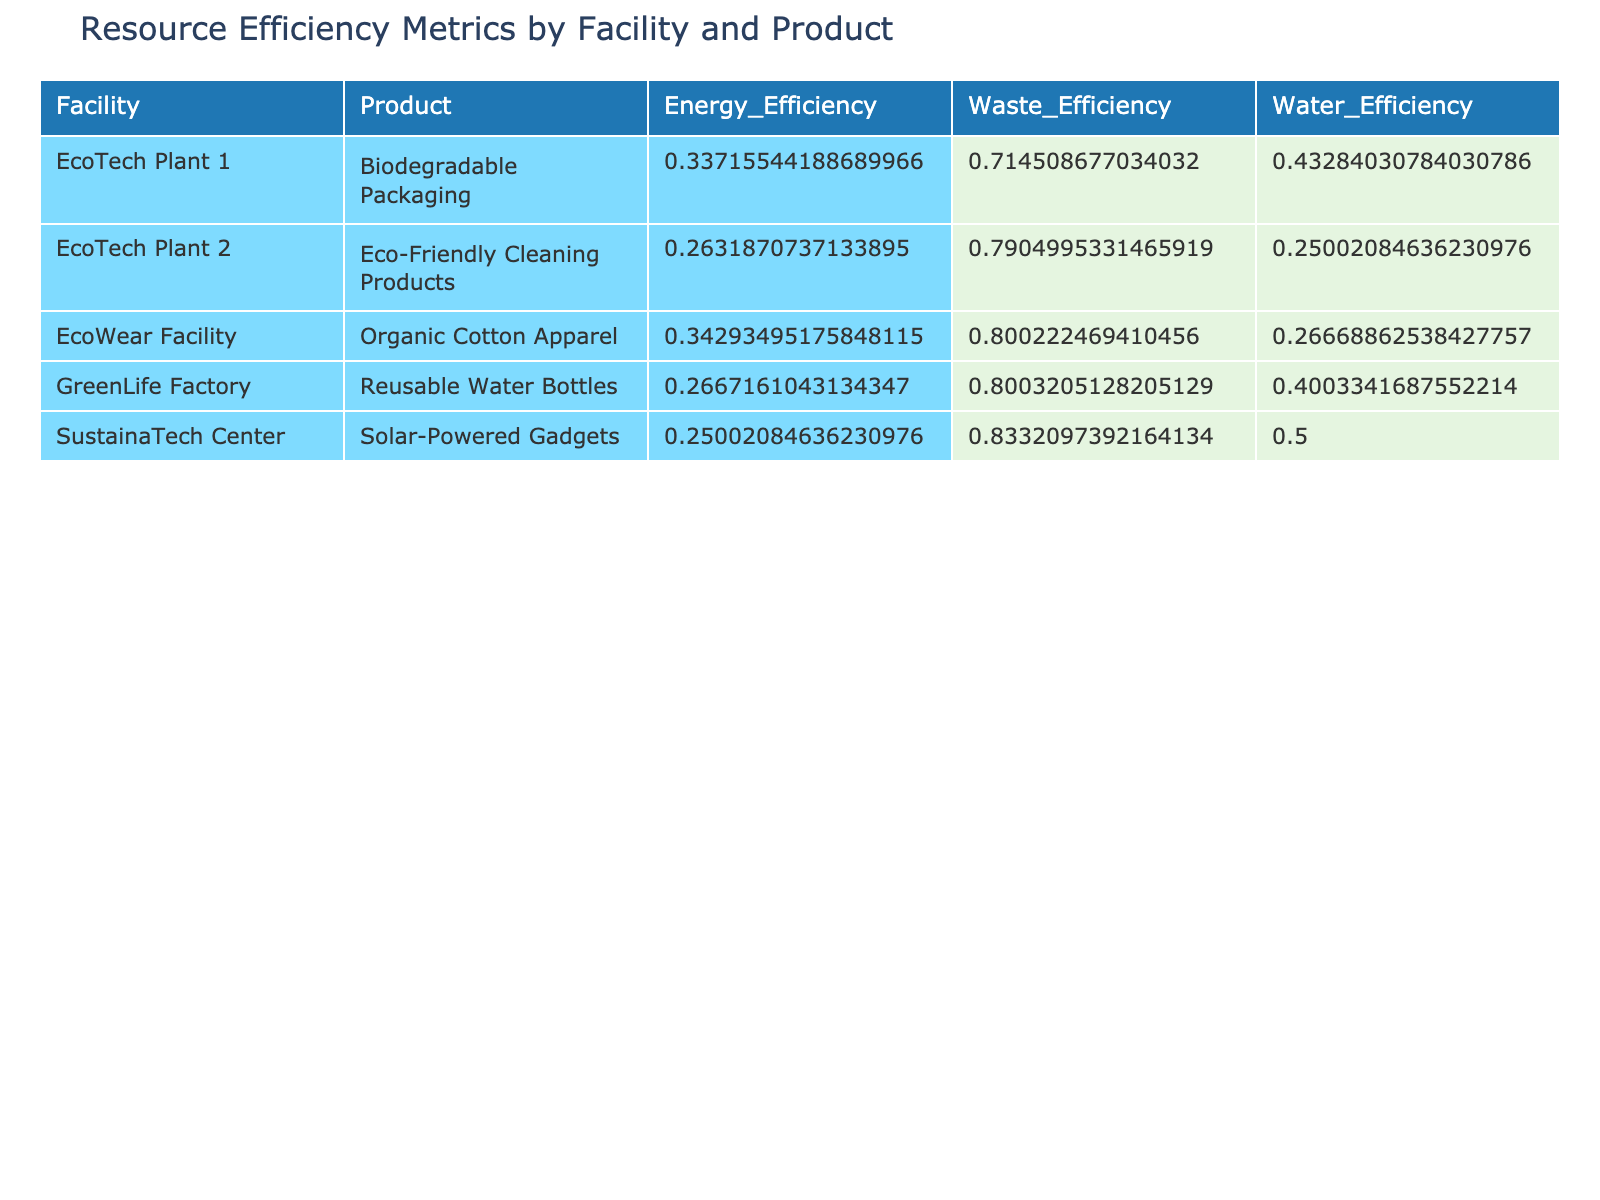What is the energy efficiency of EcoTech Plant 1 for the Biodegradable Packaging product? The table shows the energy efficiency metric under "Energy_Efficiency" for EcoTech Plant 1, Biodegradable Packaging listed as the average of its monthly values. Adding the values (0.333, 0.341, 0.326) gives 1.00, and dividing by 3 results in an average energy efficiency of approximately 0.333 kWh per production unit.
Answer: 0.333 Which facility produces the most waste per production unit? To find this, we compare the Waste Efficiency metrics. The waste efficiency values from the table show that the facility with the lowest value indicates the most waste produced per production unit, which is EcoTech Plant 1 for Biodegradable Packaging, with values averaging waste efficiency of 0.705.
Answer: EcoTech Plant 1 Is the water usage efficiency for EcoWear Facility higher than that for EcoTech Plant 2? From the table, EcoWear Facility's water efficiency averages to approximately 0.266, while EcoTech Plant 2's averages to 0.263. Comparing these values shows that EcoWear Facility has slightly higher water usage efficiency than EcoTech Plant 2 by about 0.003.
Answer: Yes What is the average waste produced across all facilities for the month of January? To calculate this, we first sum all waste produced in January: (8500 + 7000 + 5000 + 3000 + 6000) = 29000 kg. Then, we divide by the number of facilities (5), giving an average waste produced per facility of 5800 kg for January.
Answer: 5800 kg Which product had the best energy efficiency across all facilities on average? The energy efficiency values should be averaged for each product: (both the energy efficiencies calculated above). Biodegradable Packaging from EcoTech Plant 1 averaged 0.333, Eco-Friendly Cleaning Products from EcoTech Plant 2 averaged 0.263, Reusable Water Bottles from GreenLife Factory averaged 0.330 , Solar-Powered Gadgets from SustainaTech Center averaged 0.252, and Organic Cotton Apparel from EcoWear had it average 0.300. The highest average belongs to Biodegradable Packaging.
Answer: Biodegradable Packaging Is the amount of waste recycled in GreenLife Factory greater than 50% of its total waste produced in any month? We will check the waste efficiency values per month for GreenLife Factory. For January, it recycled approximately 80% of total waste, for February around 81.25%, and for March close to 78.85%. Since all values are above 50%, the answer is yes.
Answer: Yes What is the difference in water usage efficiency between the most and least efficient facility? The most efficient in water usage from the table is EcoWear Facility, averaging 0.274, and the least efficient is SustainaTech Center, averaging 0.196. The difference in efficiency is calculated as 0.274 - 0.196 = 0.078.
Answer: 0.078 